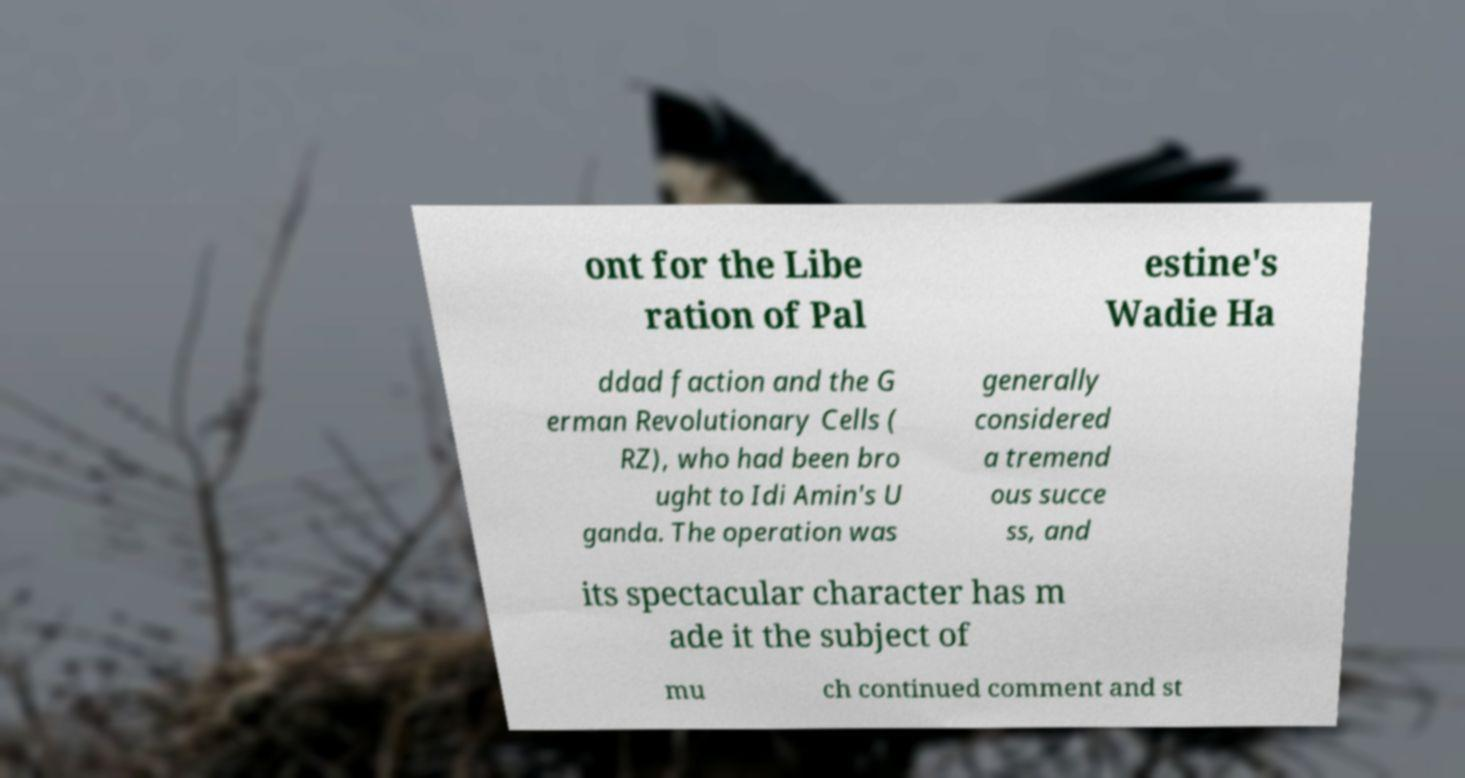For documentation purposes, I need the text within this image transcribed. Could you provide that? ont for the Libe ration of Pal estine's Wadie Ha ddad faction and the G erman Revolutionary Cells ( RZ), who had been bro ught to Idi Amin's U ganda. The operation was generally considered a tremend ous succe ss, and its spectacular character has m ade it the subject of mu ch continued comment and st 